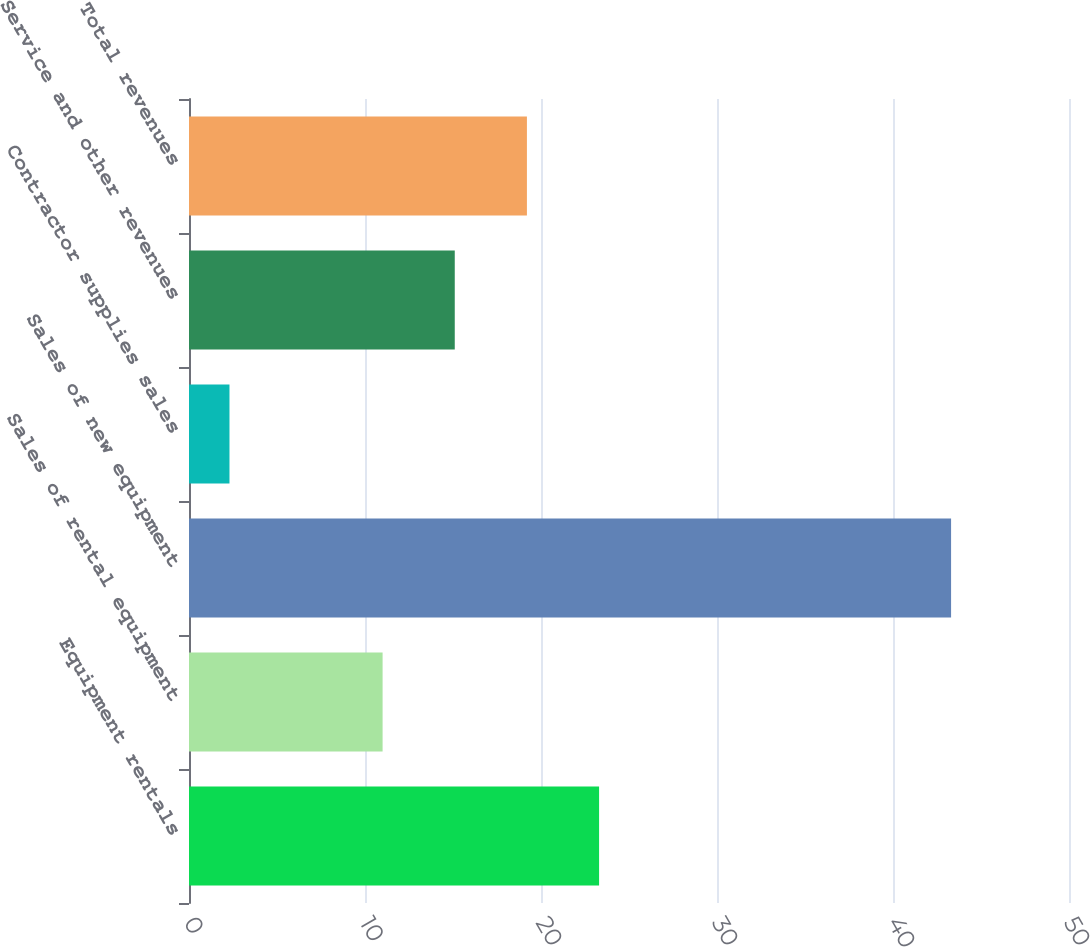<chart> <loc_0><loc_0><loc_500><loc_500><bar_chart><fcel>Equipment rentals<fcel>Sales of rental equipment<fcel>Sales of new equipment<fcel>Contractor supplies sales<fcel>Service and other revenues<fcel>Total revenues<nl><fcel>23.3<fcel>11<fcel>43.3<fcel>2.3<fcel>15.1<fcel>19.2<nl></chart> 